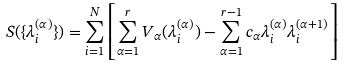Convert formula to latex. <formula><loc_0><loc_0><loc_500><loc_500>S ( \{ \lambda _ { i } ^ { ( \alpha ) } \} ) = \sum _ { i = 1 } ^ { N } \left [ \sum _ { \alpha = 1 } ^ { r } V _ { \alpha } ( \lambda _ { i } ^ { ( \alpha ) } ) - \sum _ { \alpha = 1 } ^ { r - 1 } c _ { \alpha } \lambda _ { i } ^ { ( \alpha ) } \lambda _ { i } ^ { ( \alpha + 1 ) } \right ]</formula> 